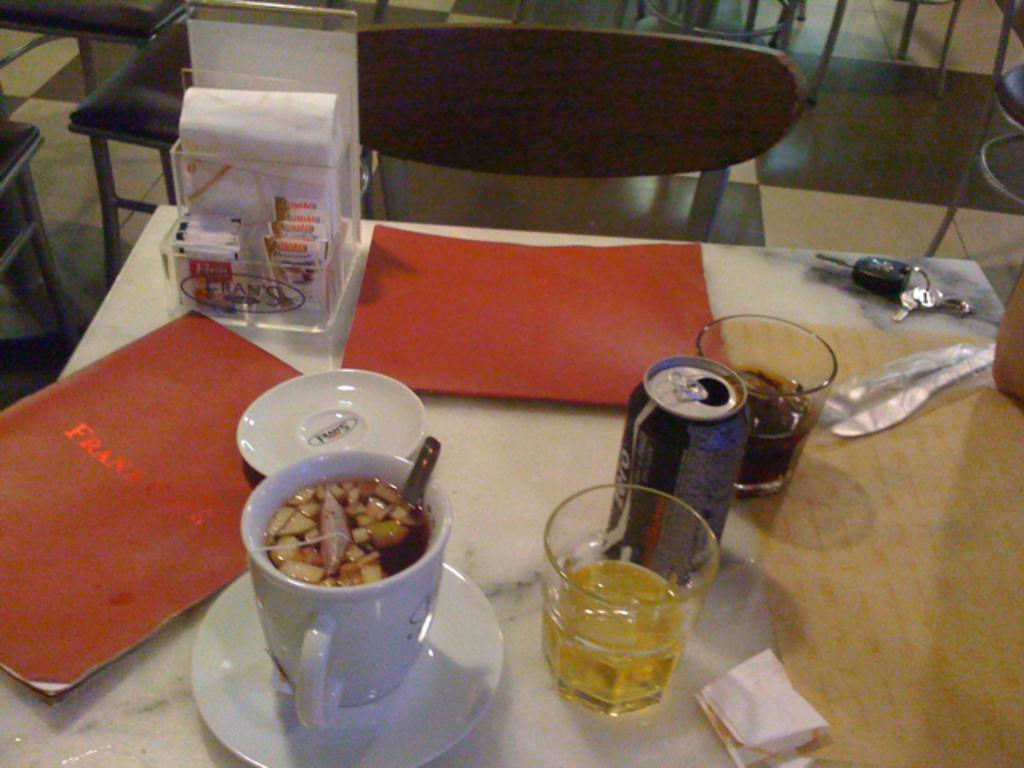What piece of furniture is present in the image? There is a table in the image. What is on the table? There is food on the table, as well as two menu cards and a key chain. What utensils are near the table? Forks are beside the table. What is near the table that people might sit on? There are chairs near the table. What type of bead is used to decorate the calendar in the image? There is no calendar present in the image, so it is not possible to determine what type of bead might be used to decorate it. 